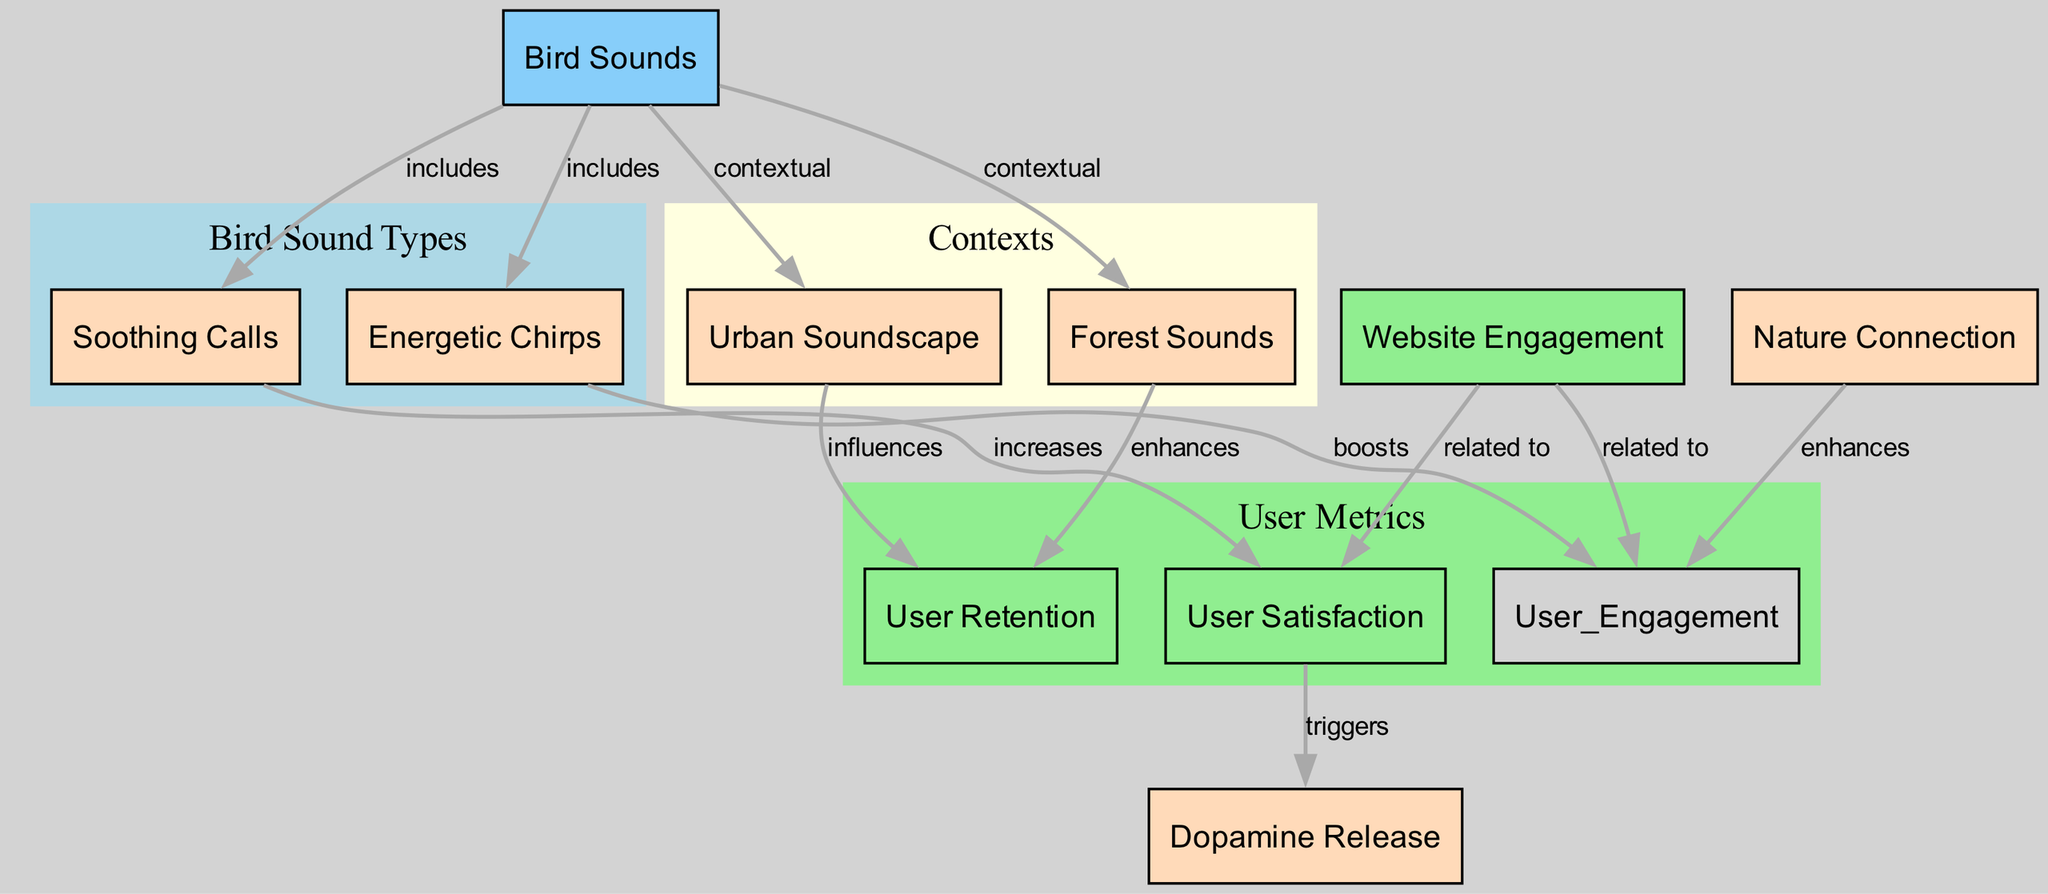What are the two types of bird sounds included in the diagram? The diagram lists "Soothing Calls" and "Energetic Chirps" as the two types of bird sounds under the "Bird Sounds" node.
Answer: Soothing Calls, Energetic Chirps How many nodes relate to user metrics in the diagram? Upon observing the diagram, the user metrics are represented by the nodes "User Retention," "User Satisfaction," and "User Engagement," which totals three nodes.
Answer: 3 What effect do soothing calls have on user satisfaction? The diagram indicates that soothing calls "increases" user satisfaction, demonstrating a positive relationship.
Answer: Increases Which context influences user retention according to the diagram? The diagram specifies two contexts: "Forest Sounds" and "Urban Soundscape," both of which have a direct influence on user retention.
Answer: Forest Sounds, Urban Soundscape What is the relationship between website engagement and user satisfaction? The diagram shows that website engagement is "related to" user satisfaction, indicating a direct correlation between the two concepts.
Answer: Related to What triggers dopamine release in the context of user experience? According to the diagram, user satisfaction "triggers" dopamine release, suggesting that a higher level of satisfaction leads to this biological response.
Answer: Triggers How does nature connection affect user engagement? The diagram indicates that nature connection "enhances" user engagement, suggesting a positive impact of nature-related stimuli on user interaction with websites.
Answer: Enhances What node has a contextual relationship with bird sounds? The edges in the diagram show that both "Forest Sounds" and "Urban Soundscape" have a contextual relationship with the broader "Bird Sounds" node.
Answer: Forest Sounds, Urban Soundscape What is the impact of energetic chirps on user engagement? The diagram states that energetic chirps "boosts" user engagement, illustrating a beneficial effect on how users interact with the website.
Answer: Boosts 